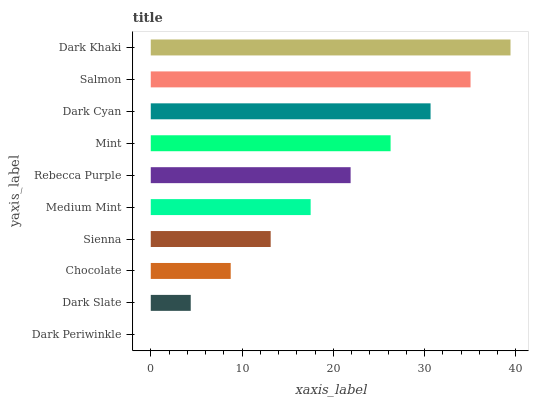Is Dark Periwinkle the minimum?
Answer yes or no. Yes. Is Dark Khaki the maximum?
Answer yes or no. Yes. Is Dark Slate the minimum?
Answer yes or no. No. Is Dark Slate the maximum?
Answer yes or no. No. Is Dark Slate greater than Dark Periwinkle?
Answer yes or no. Yes. Is Dark Periwinkle less than Dark Slate?
Answer yes or no. Yes. Is Dark Periwinkle greater than Dark Slate?
Answer yes or no. No. Is Dark Slate less than Dark Periwinkle?
Answer yes or no. No. Is Rebecca Purple the high median?
Answer yes or no. Yes. Is Medium Mint the low median?
Answer yes or no. Yes. Is Salmon the high median?
Answer yes or no. No. Is Salmon the low median?
Answer yes or no. No. 